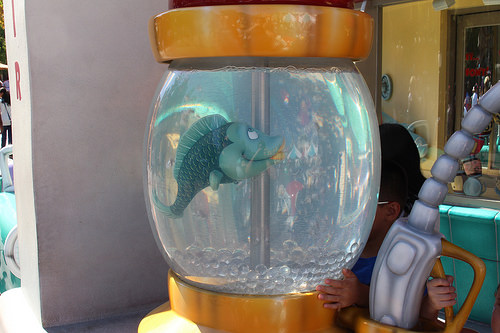<image>
Is there a fish next to the jar? No. The fish is not positioned next to the jar. They are located in different areas of the scene. Is the child in front of the fishbowl? No. The child is not in front of the fishbowl. The spatial positioning shows a different relationship between these objects. 